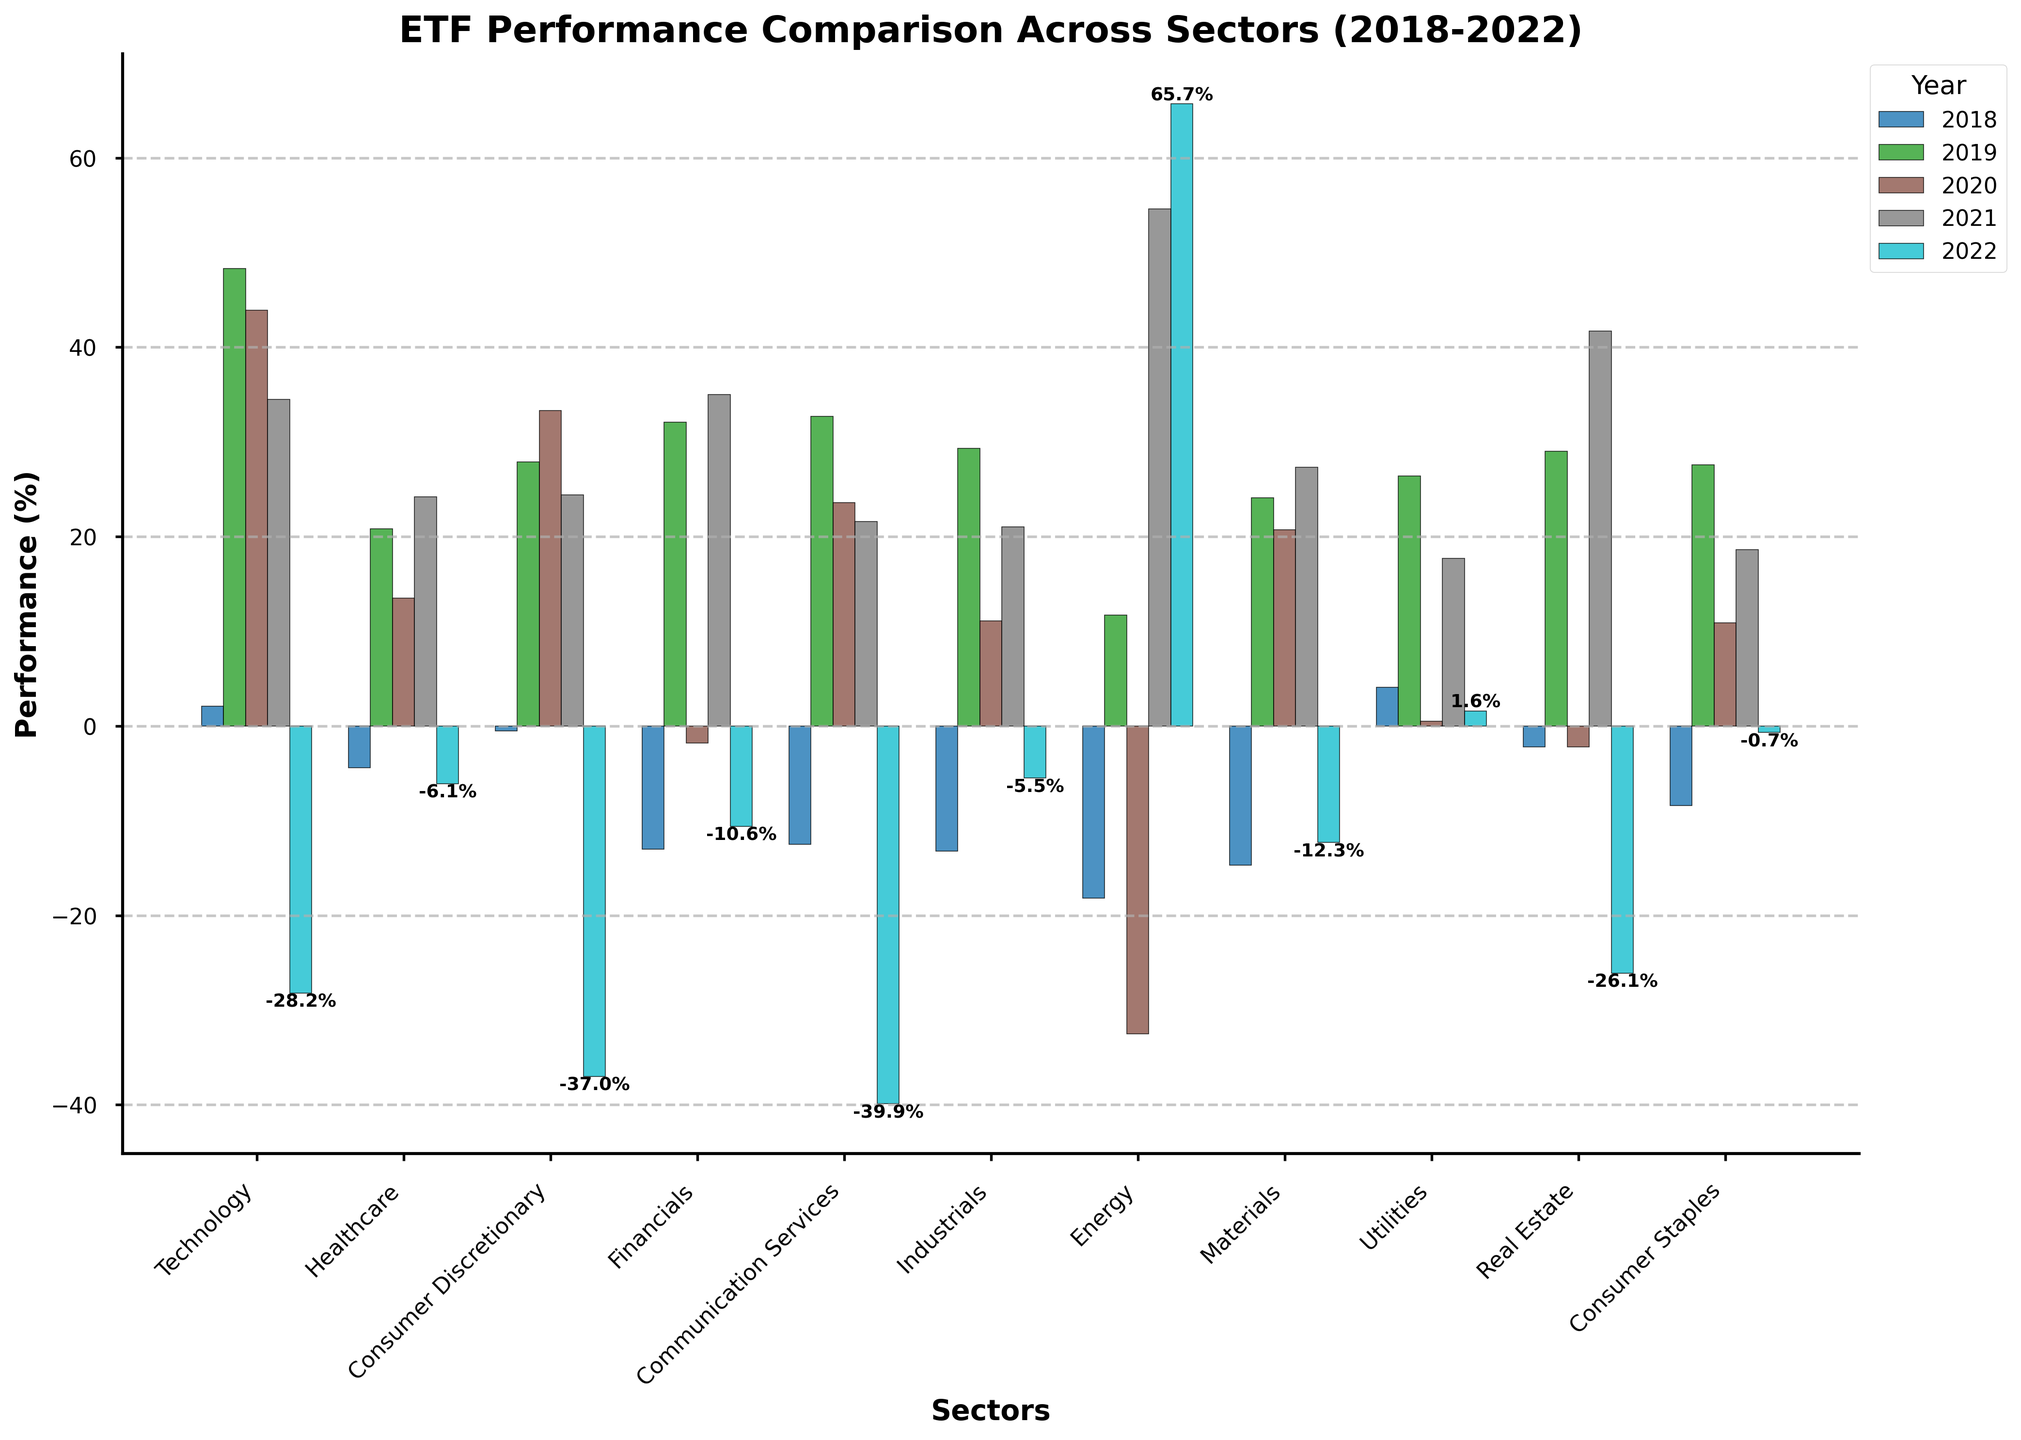Which sector had the best performance in 2022? The best performance in 2022 is indicated by the highest bar for that year. The Energy sector has the highest bar at 65.7%.
Answer: Energy Which sector had the worst performance in 2020? The worst performance in 2020 is indicated by the lowest bar for that year. The Energy sector has the lowest bar at -32.5%.
Answer: Energy Across all years, which sector showed a consistent positive performance? We need to check each sector's performance across all the years and identify the one with no negative values. Only the Utilities sector has non-negative performance every year.
Answer: Utilities What was the average performance of the Financials sector over these 5 years? To calculate the average, sum up the performance values of the Financials sector for each year and divide by the number of years: (-13.0 + 32.1 - 1.8 + 35.0 -10.6) / 5 = 8.34.
Answer: 8.34 Which year had the most sectors with negative performance? Count the number of sectors with negative performance for each year:
2018: Healthcare, Financials, Communication Services, Industrials, Energy, Materials, Real Estate, Consumer Staples (8).
2019: None (0).
2020: Financials, Energy, Real Estate (3).
2021: None (0).
2022: Technology, Healthcare, Consumer Discretionary, Financials, Communication Services, Industrials, Materials, Real Estate, Consumer Staples (9). 2022 has the most sectors with negative performance.
Answer: 2022 How did the performance of the Technology sector in 2021 compare to 2022? Compare the Technology performance values for 2021 and 2022: 34.5% in 2021 and -28.2% in 2022. A significant decline is observed.
Answer: Decline What's the difference in performance between the best and worst performing sectors in 2019? Identify the best and worst performing sectors in 2019: Technology at 48.3% and Energy at 11.7%. The difference is 48.3 - 11.7 = 36.6%.
Answer: 36.6 Which sector had the highest average performance over these 5 years? Calculate the average performance of each sector and compare. Technology: (2.1 + 48.3 + 43.9 + 34.5 - 28.2) / 5 = 20.12, Healthcare: (20.8 + 13.5 + 24.2 - 6.1 - 4.4) / 5 = 9.6, and so on. Communication Services: (20.3 + 18.6 - 73.7) / 5 = 10.58, but Energy: (-18.2 + 11.7 - 32.5 + 54.6 + 65.7) / 5 = 16.26. Technology has the highest average.
Answer: Technology 